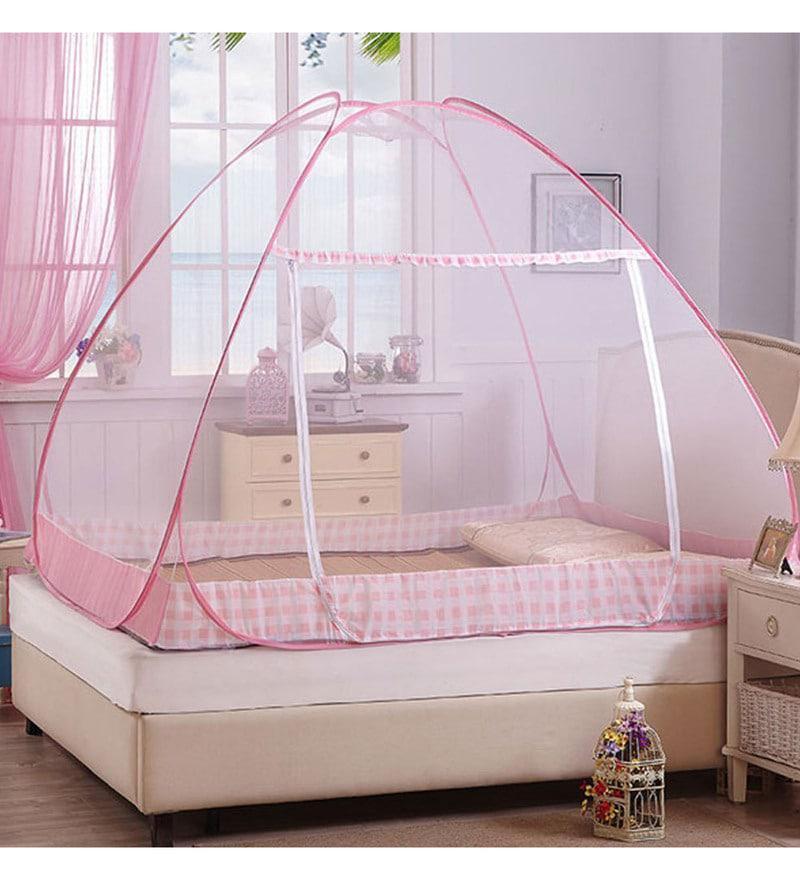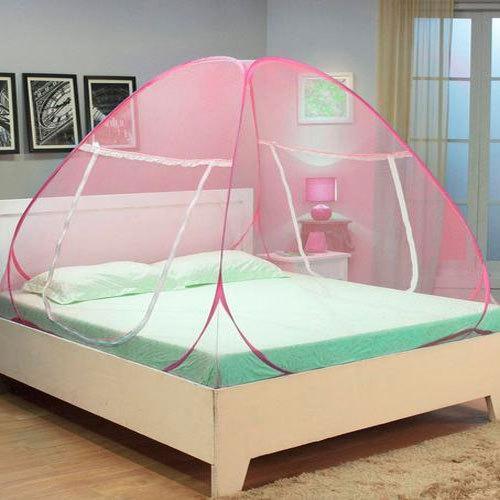The first image is the image on the left, the second image is the image on the right. For the images shown, is this caption "One bed net has a fabric bottom trim." true? Answer yes or no. Yes. The first image is the image on the left, the second image is the image on the right. For the images displayed, is the sentence "One image shows a head-on view of a bed surrounded by a square sheer white canopy that covers the foot of the bed and suspends from its top corners." factually correct? Answer yes or no. No. 